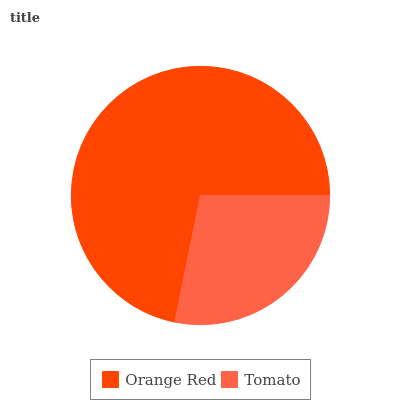Is Tomato the minimum?
Answer yes or no. Yes. Is Orange Red the maximum?
Answer yes or no. Yes. Is Tomato the maximum?
Answer yes or no. No. Is Orange Red greater than Tomato?
Answer yes or no. Yes. Is Tomato less than Orange Red?
Answer yes or no. Yes. Is Tomato greater than Orange Red?
Answer yes or no. No. Is Orange Red less than Tomato?
Answer yes or no. No. Is Orange Red the high median?
Answer yes or no. Yes. Is Tomato the low median?
Answer yes or no. Yes. Is Tomato the high median?
Answer yes or no. No. Is Orange Red the low median?
Answer yes or no. No. 